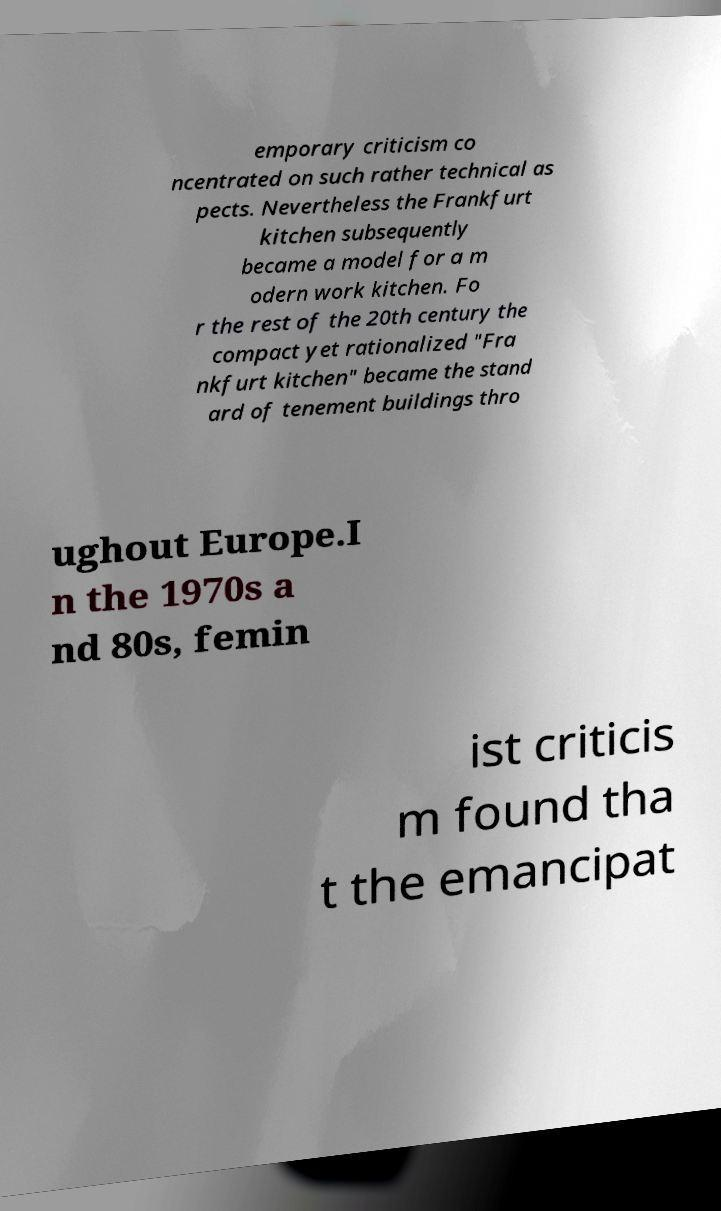For documentation purposes, I need the text within this image transcribed. Could you provide that? emporary criticism co ncentrated on such rather technical as pects. Nevertheless the Frankfurt kitchen subsequently became a model for a m odern work kitchen. Fo r the rest of the 20th century the compact yet rationalized "Fra nkfurt kitchen" became the stand ard of tenement buildings thro ughout Europe.I n the 1970s a nd 80s, femin ist criticis m found tha t the emancipat 